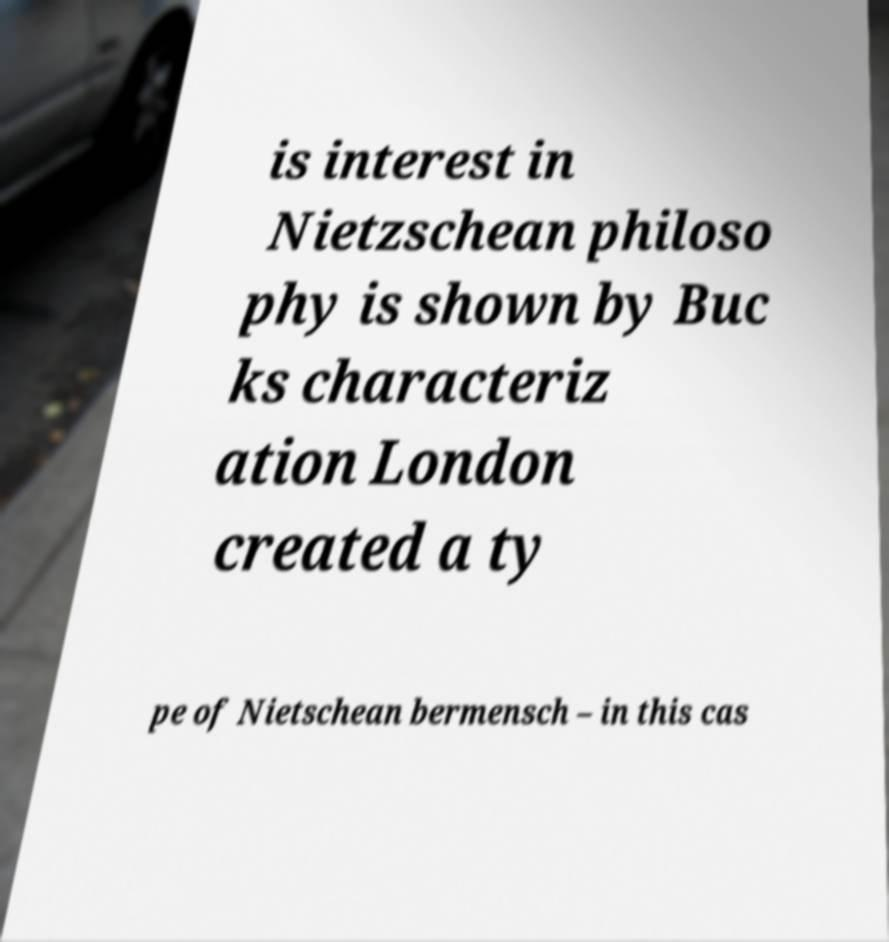I need the written content from this picture converted into text. Can you do that? is interest in Nietzschean philoso phy is shown by Buc ks characteriz ation London created a ty pe of Nietschean bermensch – in this cas 